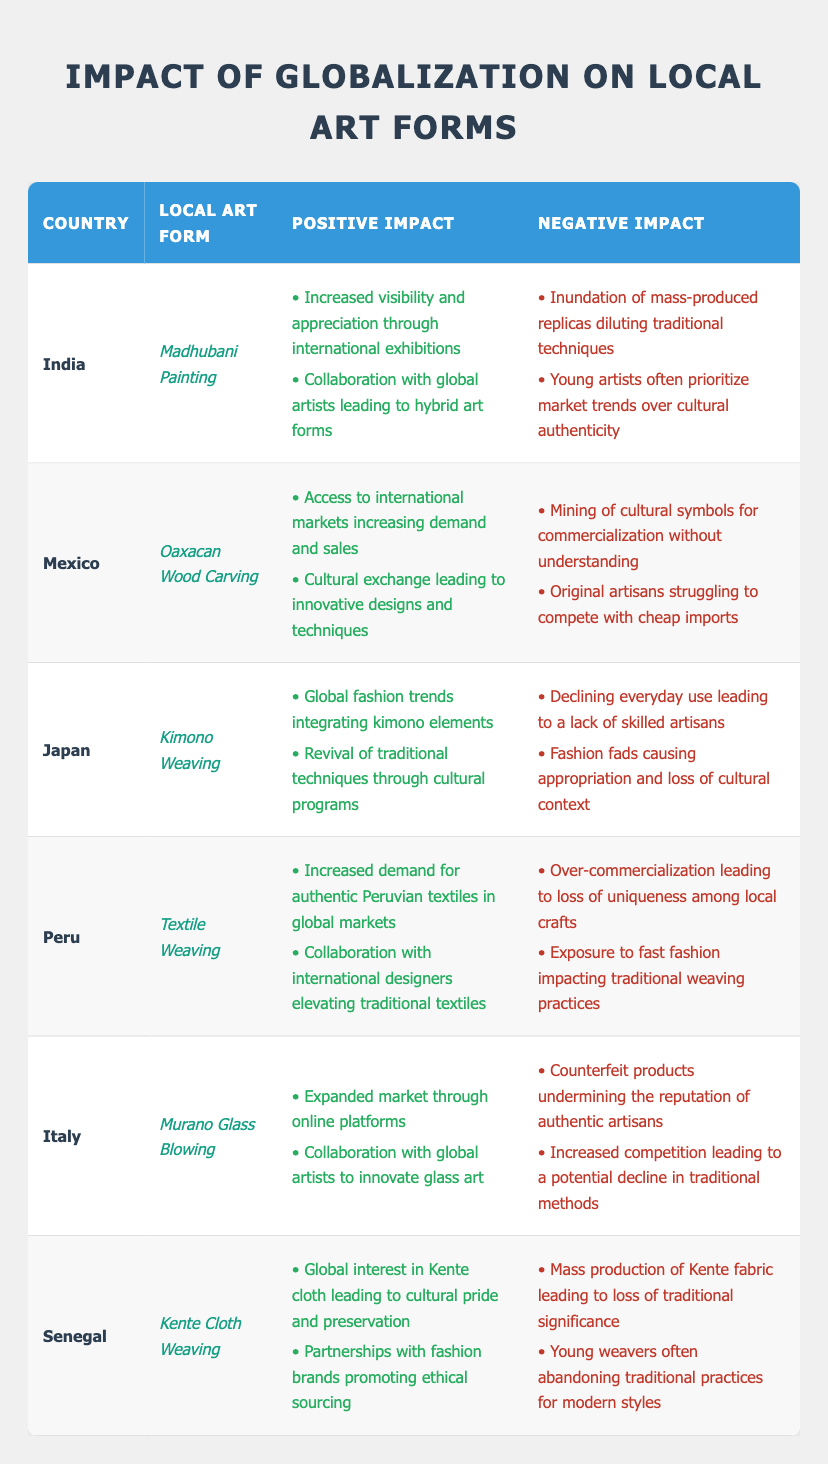What is the local art form from India? The table lists the local art forms alongside their respective countries. Referring to India, the local art form is Madhubani Painting.
Answer: Madhubani Painting Which country is associated with Kente Cloth Weaving? The table indicates the local art forms and their corresponding countries. For Kente Cloth Weaving, the associated country is Senegal.
Answer: Senegal How many positive impacts are listed for Japanese Kimono Weaving? Looking under the Japan section, there are two positive impacts for Kimono Weaving: one is about global fashion trends integrating kimono elements, and the second is about revival of traditional techniques. Thus, the total is two.
Answer: 2 Is there a negative impact for Oaxacan Wood Carving related to original artisans? By examining the Mexico section of the table, one of the negative impacts states that original artisans struggle to compete with cheap imports, which means there is indeed a negative impact concerning them.
Answer: Yes Which local art form faces over-commercialization in Peru? The table indicates under Peru that the local art form is Textile Weaving, which specifically mentions over-commercialization as leading to a loss of uniqueness among local crafts.
Answer: Textile Weaving Count how many countries have a positive impact related to increased visibility and appreciation through exhibitions. From the table, only India's Madhubani Painting specifically mentions increased visibility and appreciation through international exhibitions as a positive impact. Therefore, there is one country.
Answer: 1 What are the negative impacts for Murano Glass Blowing in Italy? Reviewing the entries for Italy, the negative impacts include counterfeit products undermining the reputation of authentic artisans and increased competition leading to potential decline in traditional methods. Therefore, the two negative impacts are as mentioned.
Answer: Counterfeit products and increased competition Which country has a positive impact associated with access to international markets? In looking at the Mexico section regarding Oaxacan Wood Carving, it states that access to international markets leads to increased demand and sales, thus confirming that Mexico has a positive impact associated with this aspect.
Answer: Mexico List the number of countries where the young artists are abandoning traditional practices for modern styles. By checking the Senegal and Peru entries, both mention young artists/weavers abandoning traditional practices for modern styles. Thus, the total count comes to two countries.
Answer: 2 